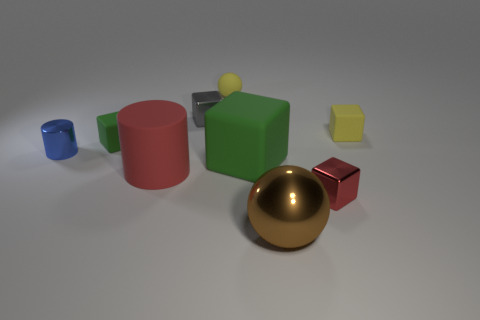What shape is the object that is the same color as the large block?
Provide a short and direct response. Cube. Are there any blocks of the same color as the matte cylinder?
Your response must be concise. Yes. How many things are either tiny objects that are to the left of the brown metal ball or things that are behind the red rubber thing?
Provide a short and direct response. 6. How many other objects are the same size as the red shiny block?
Offer a very short reply. 5. There is a matte cube that is left of the red cylinder; is its color the same as the large block?
Keep it short and to the point. Yes. What is the size of the block that is both behind the large block and right of the big block?
Your answer should be very brief. Small. What number of big things are yellow metal blocks or gray metal cubes?
Offer a very short reply. 0. What shape is the small rubber object left of the gray block?
Offer a very short reply. Cube. How many blue things are there?
Give a very brief answer. 1. Is the brown thing made of the same material as the gray cube?
Your response must be concise. Yes. 